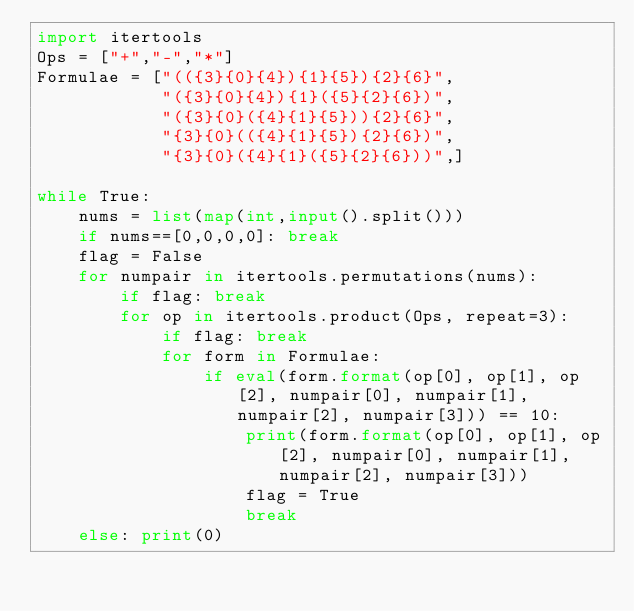<code> <loc_0><loc_0><loc_500><loc_500><_Python_>import itertools
Ops = ["+","-","*"]
Formulae = ["(({3}{0}{4}){1}{5}){2}{6}",
            "({3}{0}{4}){1}({5}{2}{6})",
            "({3}{0}({4}{1}{5})){2}{6}",
            "{3}{0}(({4}{1}{5}){2}{6})",
            "{3}{0}({4}{1}({5}{2}{6}))",]

while True:
    nums = list(map(int,input().split()))
    if nums==[0,0,0,0]: break
    flag = False
    for numpair in itertools.permutations(nums):
        if flag: break
        for op in itertools.product(Ops, repeat=3):
            if flag: break
            for form in Formulae:
                if eval(form.format(op[0], op[1], op[2], numpair[0], numpair[1], numpair[2], numpair[3])) == 10:
                    print(form.format(op[0], op[1], op[2], numpair[0], numpair[1], numpair[2], numpair[3]))
                    flag = True
                    break
    else: print(0)</code> 